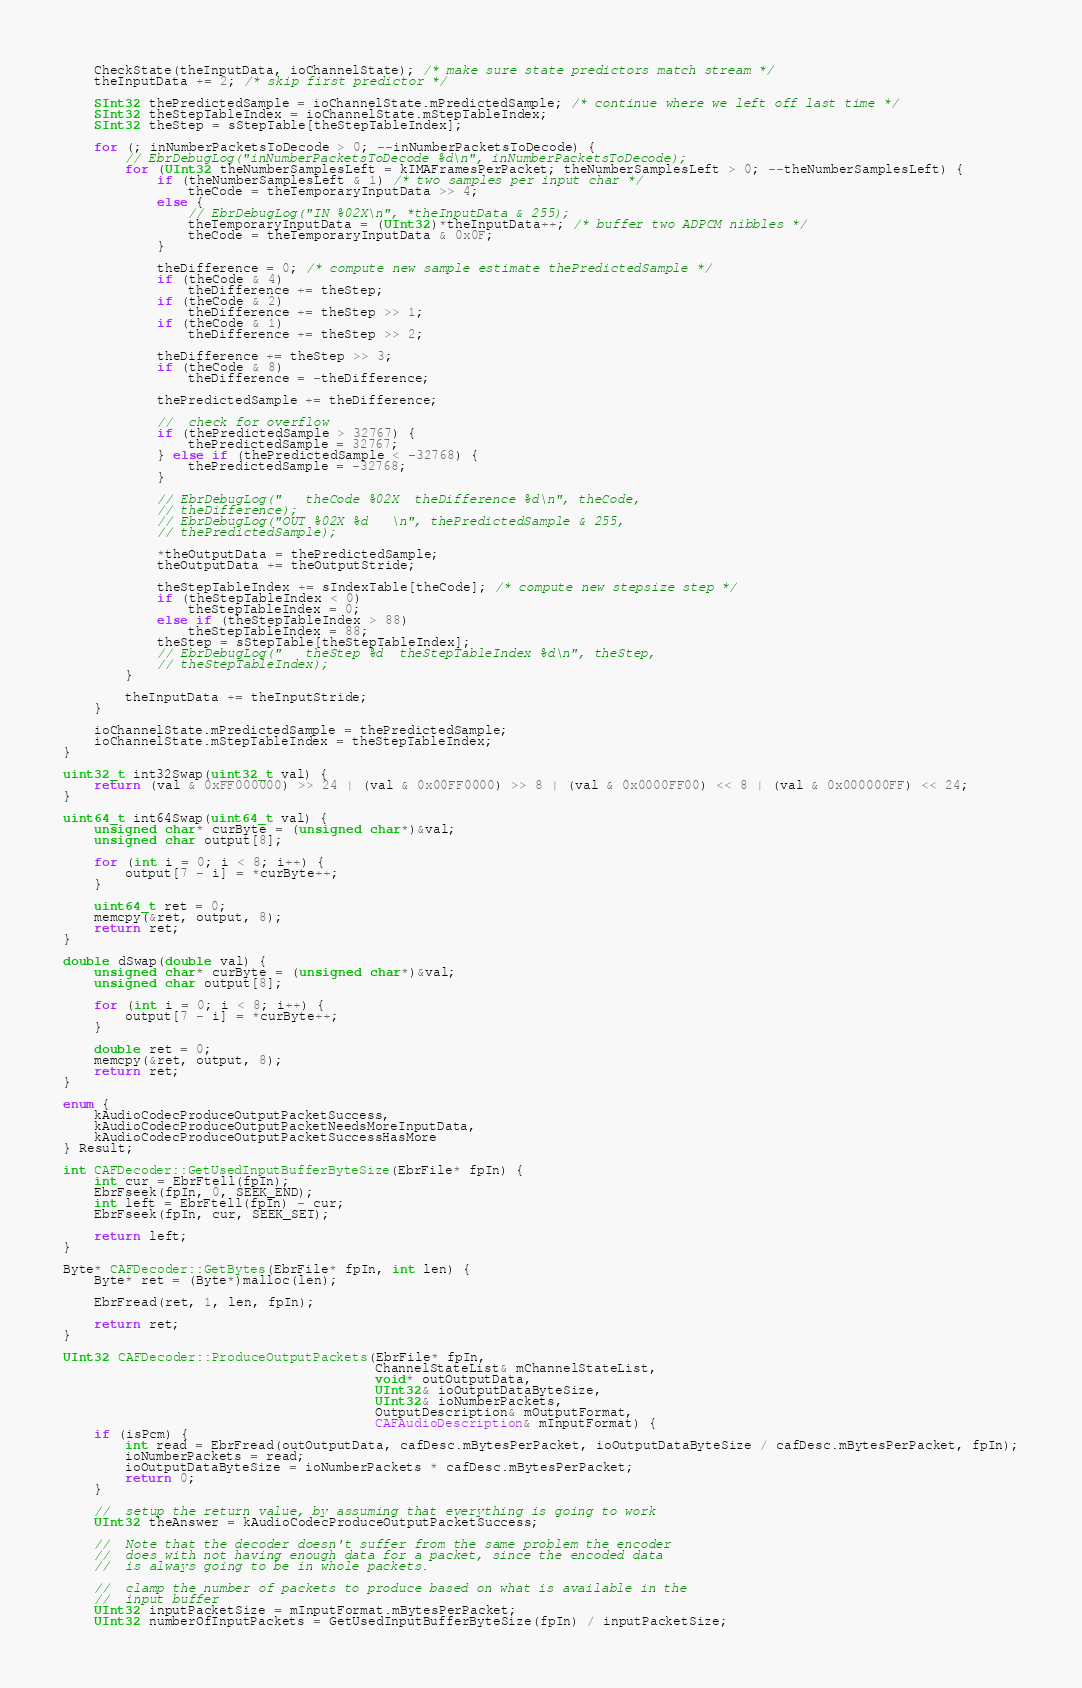<code> <loc_0><loc_0><loc_500><loc_500><_ObjectiveC_>    CheckState(theInputData, ioChannelState); /* make sure state predictors match stream */
    theInputData += 2; /* skip first predictor */

    SInt32 thePredictedSample = ioChannelState.mPredictedSample; /* continue where we left off last time */
    SInt32 theStepTableIndex = ioChannelState.mStepTableIndex;
    SInt32 theStep = sStepTable[theStepTableIndex];

    for (; inNumberPacketsToDecode > 0; --inNumberPacketsToDecode) {
        // EbrDebugLog("inNumberPacketsToDecode %d\n", inNumberPacketsToDecode);
        for (UInt32 theNumberSamplesLeft = kIMAFramesPerPacket; theNumberSamplesLeft > 0; --theNumberSamplesLeft) {
            if (theNumberSamplesLeft & 1) /* two samples per input char */
                theCode = theTemporaryInputData >> 4;
            else {
                // EbrDebugLog("IN %02X\n", *theInputData & 255);
                theTemporaryInputData = (UInt32)*theInputData++; /* buffer two ADPCM nibbles */
                theCode = theTemporaryInputData & 0x0F;
            }

            theDifference = 0; /* compute new sample estimate thePredictedSample */
            if (theCode & 4)
                theDifference += theStep;
            if (theCode & 2)
                theDifference += theStep >> 1;
            if (theCode & 1)
                theDifference += theStep >> 2;

            theDifference += theStep >> 3;
            if (theCode & 8)
                theDifference = -theDifference;

            thePredictedSample += theDifference;

            //  check for overflow
            if (thePredictedSample > 32767) {
                thePredictedSample = 32767;
            } else if (thePredictedSample < -32768) {
                thePredictedSample = -32768;
            }

            // EbrDebugLog("   theCode %02X  theDifference %d\n", theCode,
            // theDifference);
            // EbrDebugLog("OUT %02X %d   \n", thePredictedSample & 255,
            // thePredictedSample);

            *theOutputData = thePredictedSample;
            theOutputData += theOutputStride;

            theStepTableIndex += sIndexTable[theCode]; /* compute new stepsize step */
            if (theStepTableIndex < 0)
                theStepTableIndex = 0;
            else if (theStepTableIndex > 88)
                theStepTableIndex = 88;
            theStep = sStepTable[theStepTableIndex];
            // EbrDebugLog("   theStep %d  theStepTableIndex %d\n", theStep,
            // theStepTableIndex);
        }

        theInputData += theInputStride;
    }

    ioChannelState.mPredictedSample = thePredictedSample;
    ioChannelState.mStepTableIndex = theStepTableIndex;
}

uint32_t int32Swap(uint32_t val) {
    return (val & 0xFF000000) >> 24 | (val & 0x00FF0000) >> 8 | (val & 0x0000FF00) << 8 | (val & 0x000000FF) << 24;
}

uint64_t int64Swap(uint64_t val) {
    unsigned char* curByte = (unsigned char*)&val;
    unsigned char output[8];

    for (int i = 0; i < 8; i++) {
        output[7 - i] = *curByte++;
    }

    uint64_t ret = 0;
    memcpy(&ret, output, 8);
    return ret;
}

double dSwap(double val) {
    unsigned char* curByte = (unsigned char*)&val;
    unsigned char output[8];

    for (int i = 0; i < 8; i++) {
        output[7 - i] = *curByte++;
    }

    double ret = 0;
    memcpy(&ret, output, 8);
    return ret;
}

enum {
    kAudioCodecProduceOutputPacketSuccess,
    kAudioCodecProduceOutputPacketNeedsMoreInputData,
    kAudioCodecProduceOutputPacketSuccessHasMore
} Result;

int CAFDecoder::GetUsedInputBufferByteSize(EbrFile* fpIn) {
    int cur = EbrFtell(fpIn);
    EbrFseek(fpIn, 0, SEEK_END);
    int left = EbrFtell(fpIn) - cur;
    EbrFseek(fpIn, cur, SEEK_SET);

    return left;
}

Byte* CAFDecoder::GetBytes(EbrFile* fpIn, int len) {
    Byte* ret = (Byte*)malloc(len);

    EbrFread(ret, 1, len, fpIn);

    return ret;
}

UInt32 CAFDecoder::ProduceOutputPackets(EbrFile* fpIn,
                                        ChannelStateList& mChannelStateList,
                                        void* outOutputData,
                                        UInt32& ioOutputDataByteSize,
                                        UInt32& ioNumberPackets,
                                        OutputDescription& mOutputFormat,
                                        CAFAudioDescription& mInputFormat) {
    if (isPcm) {
        int read = EbrFread(outOutputData, cafDesc.mBytesPerPacket, ioOutputDataByteSize / cafDesc.mBytesPerPacket, fpIn);
        ioNumberPackets = read;
        ioOutputDataByteSize = ioNumberPackets * cafDesc.mBytesPerPacket;
        return 0;
    }

    //  setup the return value, by assuming that everything is going to work
    UInt32 theAnswer = kAudioCodecProduceOutputPacketSuccess;

    //  Note that the decoder doesn't suffer from the same problem the encoder
    //  does with not having enough data for a packet, since the encoded data
    //  is always going to be in whole packets.

    //  clamp the number of packets to produce based on what is available in the
    //  input buffer
    UInt32 inputPacketSize = mInputFormat.mBytesPerPacket;
    UInt32 numberOfInputPackets = GetUsedInputBufferByteSize(fpIn) / inputPacketSize;</code> 